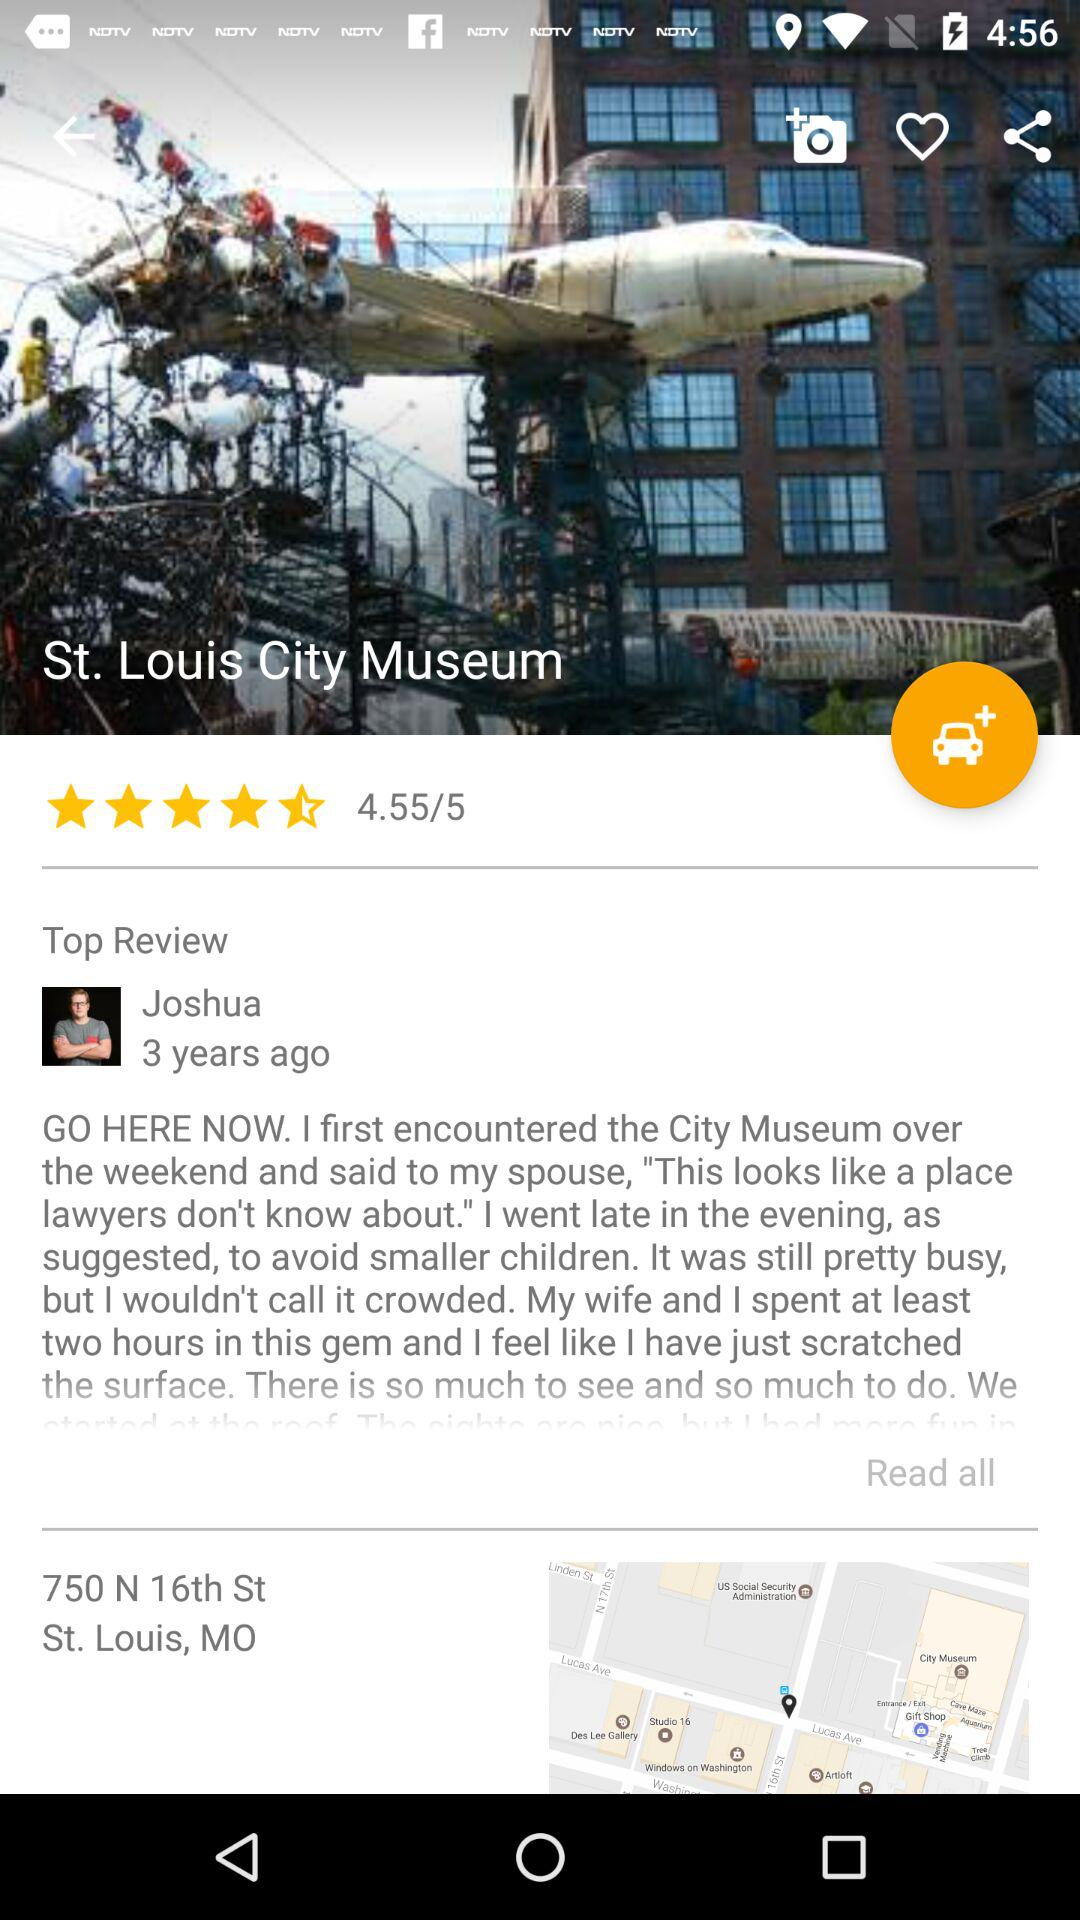How many stars are given to the "St. Louis City Museum"? There are 4.55 stars given to the "St. Louis City Museum". 